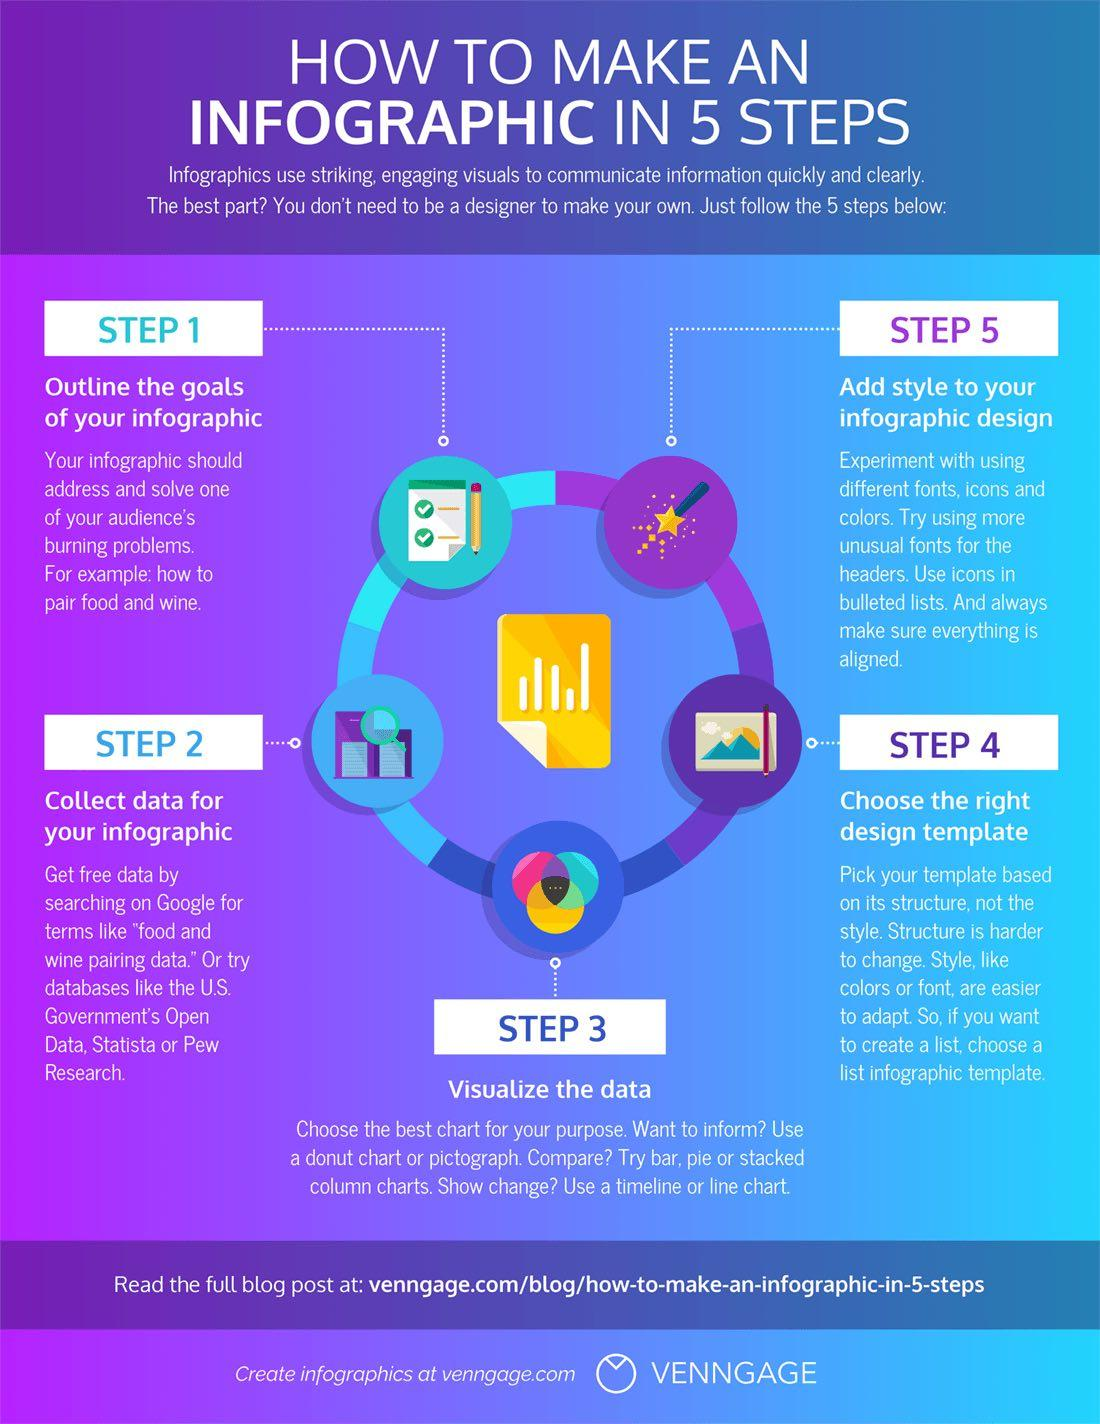Specify some key components in this picture. The third step in creating an infographic is to collect data for your infographic. The fifth step in creating an infographic is to add style to the infographic design. 